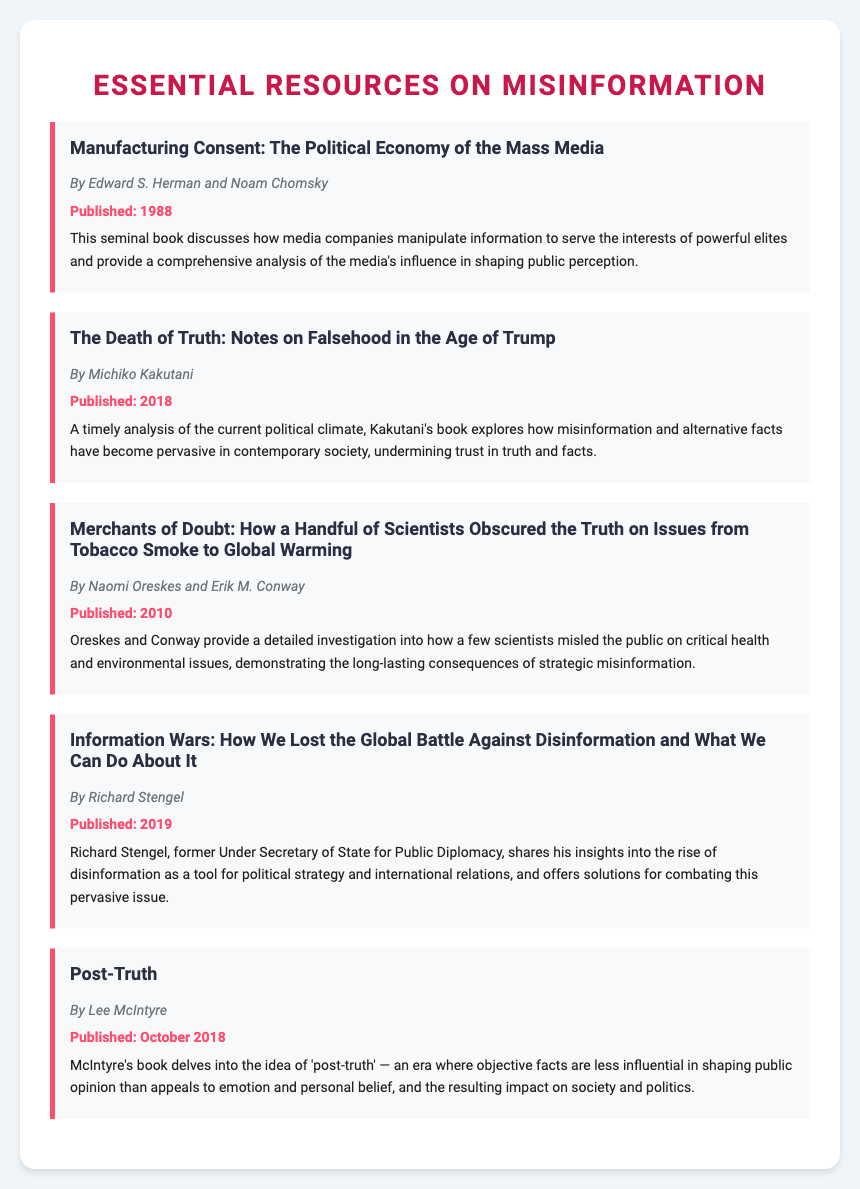What is the title of the first book? The first book listed in the document is the title "Manufacturing Consent: The Political Economy of the Mass Media."
Answer: Manufacturing Consent: The Political Economy of the Mass Media Who are the authors of "The Death of Truth"? The authors of "The Death of Truth" are Michiko Kakutani.
Answer: Michiko Kakutani What year was "Merchants of Doubt" published? The document states that "Merchants of Doubt" was published in 2010.
Answer: 2010 What is the main topic of "Post-Truth"? "Post-Truth" dives into the era of 'post-truth' and its impact on society and politics.
Answer: Impact on society and politics Which book discusses misinformation in the context of political strategy? The book that discusses misinformation in the context of political strategy is "Information Wars."
Answer: Information Wars What is the publication date of "Post-Truth"? The publication date of "Post-Truth" is noted as October 2018.
Answer: October 2018 Who wrote "Merchants of Doubt"? The authors of "Merchants of Doubt" are Naomi Oreskes and Erik M. Conway.
Answer: Naomi Oreskes and Erik M. Conway What color is used for the book titles in the document? The book titles are displayed in the color specified by the styling in the document, which is a dark gray.
Answer: Dark gray Which book addresses the consequences of alternative facts? "The Death of Truth: Notes on Falsehood in the Age of Trump" addresses the consequences of alternative facts.
Answer: The Death of Truth: Notes on Falsehood in the Age of Trump 